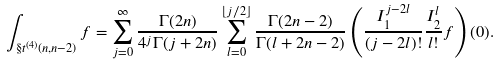Convert formula to latex. <formula><loc_0><loc_0><loc_500><loc_500>\int _ { \S t ^ { ( 4 ) } ( n , n - 2 ) } f = \sum _ { j = 0 } ^ { \infty } \frac { \Gamma ( 2 n ) } { 4 ^ { j } \Gamma ( j + 2 n ) } \sum _ { l = 0 } ^ { \lfloor j / 2 \rfloor } \frac { \Gamma ( 2 n - 2 ) } { \Gamma ( l + 2 n - 2 ) } \left ( \frac { I _ { 1 } ^ { j - 2 l } } { ( j - 2 l ) ! } \frac { I _ { 2 } ^ { l } } { l ! } f \right ) ( 0 ) .</formula> 